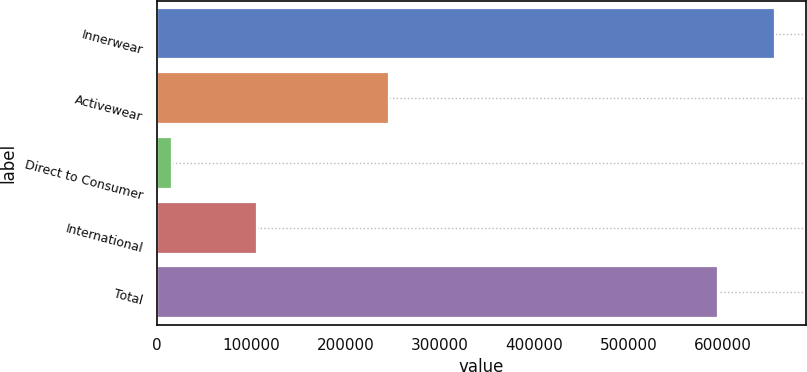<chart> <loc_0><loc_0><loc_500><loc_500><bar_chart><fcel>Innerwear<fcel>Activewear<fcel>Direct to Consumer<fcel>International<fcel>Total<nl><fcel>655873<fcel>246508<fcel>15859<fcel>105515<fcel>595118<nl></chart> 